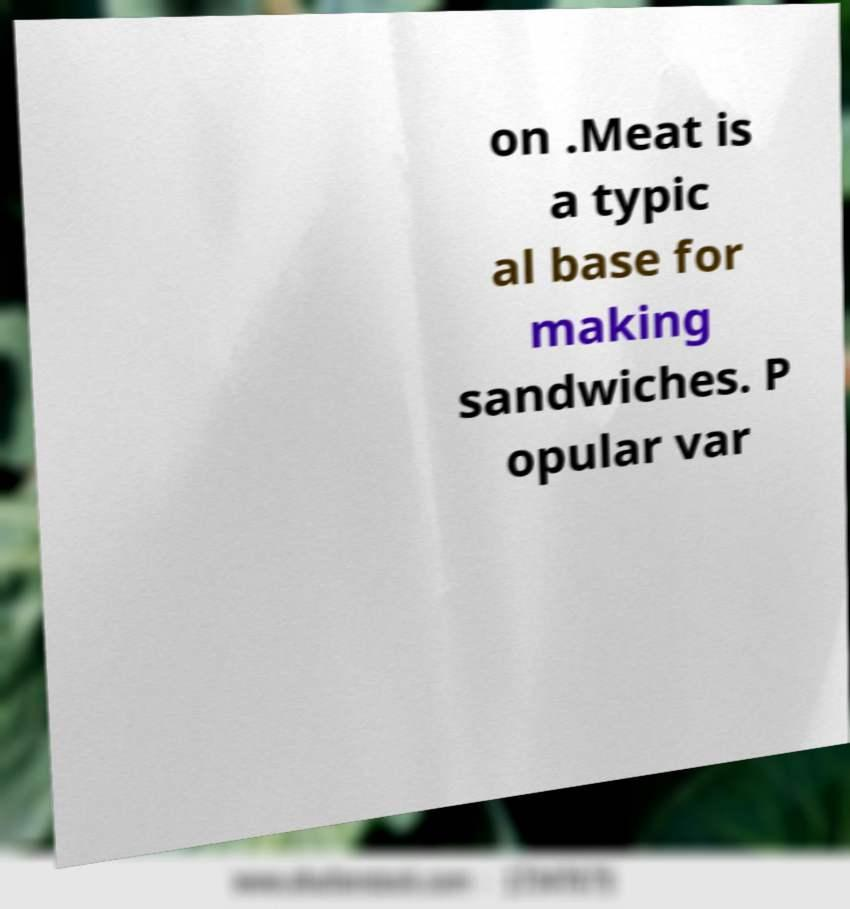Could you assist in decoding the text presented in this image and type it out clearly? on .Meat is a typic al base for making sandwiches. P opular var 